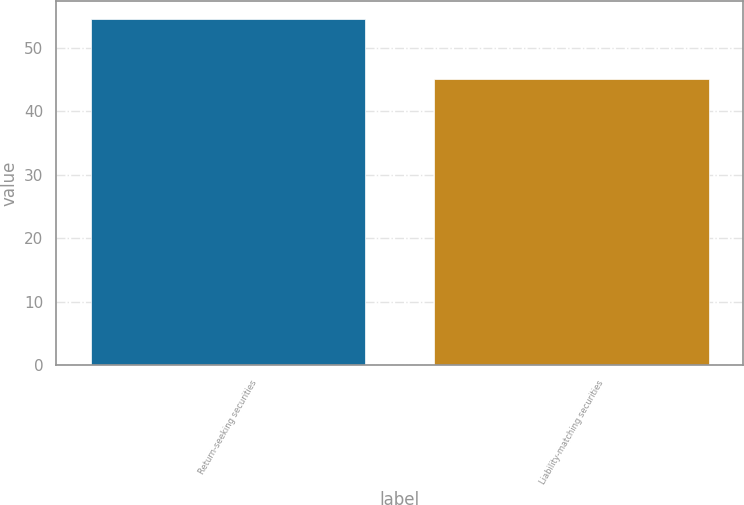Convert chart. <chart><loc_0><loc_0><loc_500><loc_500><bar_chart><fcel>Return-seeking securities<fcel>Liability-matching securities<nl><fcel>54.6<fcel>45.1<nl></chart> 